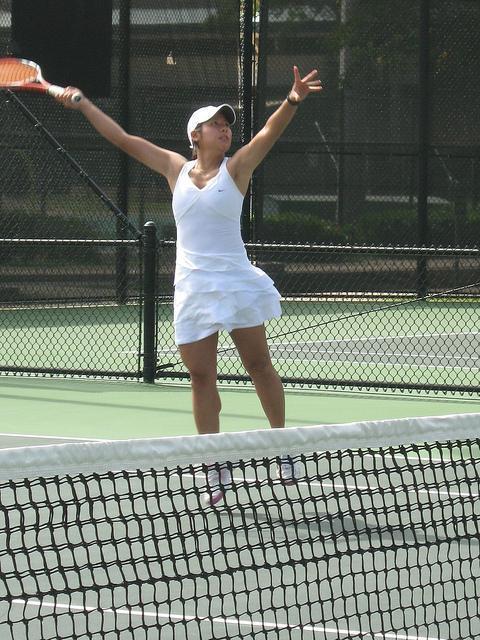How many kites are flying higher than higher than 10 feet?
Give a very brief answer. 0. 